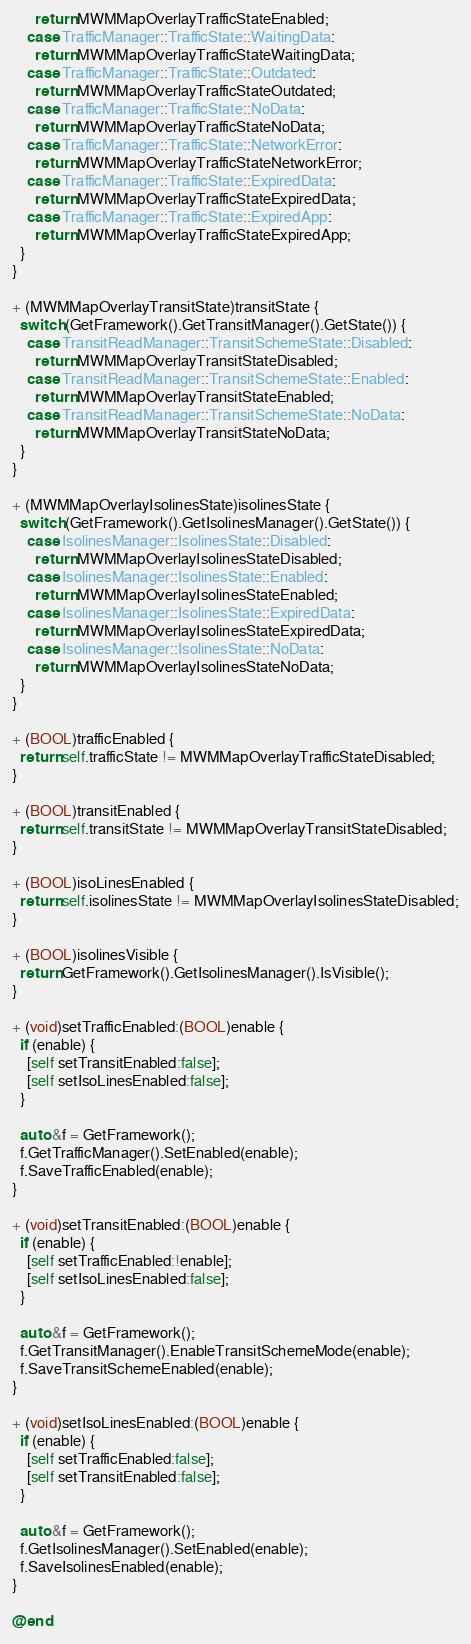<code> <loc_0><loc_0><loc_500><loc_500><_ObjectiveC_>      return MWMMapOverlayTrafficStateEnabled;
    case TrafficManager::TrafficState::WaitingData:
      return MWMMapOverlayTrafficStateWaitingData;
    case TrafficManager::TrafficState::Outdated:
      return MWMMapOverlayTrafficStateOutdated;
    case TrafficManager::TrafficState::NoData:
      return MWMMapOverlayTrafficStateNoData;
    case TrafficManager::TrafficState::NetworkError:
      return MWMMapOverlayTrafficStateNetworkError;
    case TrafficManager::TrafficState::ExpiredData:
      return MWMMapOverlayTrafficStateExpiredData;
    case TrafficManager::TrafficState::ExpiredApp:
      return MWMMapOverlayTrafficStateExpiredApp;
  }
}

+ (MWMMapOverlayTransitState)transitState {
  switch (GetFramework().GetTransitManager().GetState()) {
    case TransitReadManager::TransitSchemeState::Disabled:
      return MWMMapOverlayTransitStateDisabled;
    case TransitReadManager::TransitSchemeState::Enabled:
      return MWMMapOverlayTransitStateEnabled;
    case TransitReadManager::TransitSchemeState::NoData:
      return MWMMapOverlayTransitStateNoData;
  }
}

+ (MWMMapOverlayIsolinesState)isolinesState {
  switch (GetFramework().GetIsolinesManager().GetState()) {
    case IsolinesManager::IsolinesState::Disabled:
      return MWMMapOverlayIsolinesStateDisabled;
    case IsolinesManager::IsolinesState::Enabled:
      return MWMMapOverlayIsolinesStateEnabled;
    case IsolinesManager::IsolinesState::ExpiredData:
      return MWMMapOverlayIsolinesStateExpiredData;
    case IsolinesManager::IsolinesState::NoData:
      return MWMMapOverlayIsolinesStateNoData;
  }
}

+ (BOOL)trafficEnabled {
  return self.trafficState != MWMMapOverlayTrafficStateDisabled;
}

+ (BOOL)transitEnabled {
  return self.transitState != MWMMapOverlayTransitStateDisabled;
}

+ (BOOL)isoLinesEnabled {
  return self.isolinesState != MWMMapOverlayIsolinesStateDisabled;
}

+ (BOOL)isolinesVisible {
  return GetFramework().GetIsolinesManager().IsVisible();
}

+ (void)setTrafficEnabled:(BOOL)enable {
  if (enable) {
    [self setTransitEnabled:false];
    [self setIsoLinesEnabled:false];
  }

  auto &f = GetFramework();
  f.GetTrafficManager().SetEnabled(enable);
  f.SaveTrafficEnabled(enable);
}

+ (void)setTransitEnabled:(BOOL)enable {
  if (enable) {
    [self setTrafficEnabled:!enable];
    [self setIsoLinesEnabled:false];
  }

  auto &f = GetFramework();
  f.GetTransitManager().EnableTransitSchemeMode(enable);
  f.SaveTransitSchemeEnabled(enable);
}

+ (void)setIsoLinesEnabled:(BOOL)enable {
  if (enable) {
    [self setTrafficEnabled:false];
    [self setTransitEnabled:false];
  }

  auto &f = GetFramework();
  f.GetIsolinesManager().SetEnabled(enable);
  f.SaveIsolinesEnabled(enable);
}

@end
</code> 